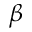<formula> <loc_0><loc_0><loc_500><loc_500>\beta</formula> 